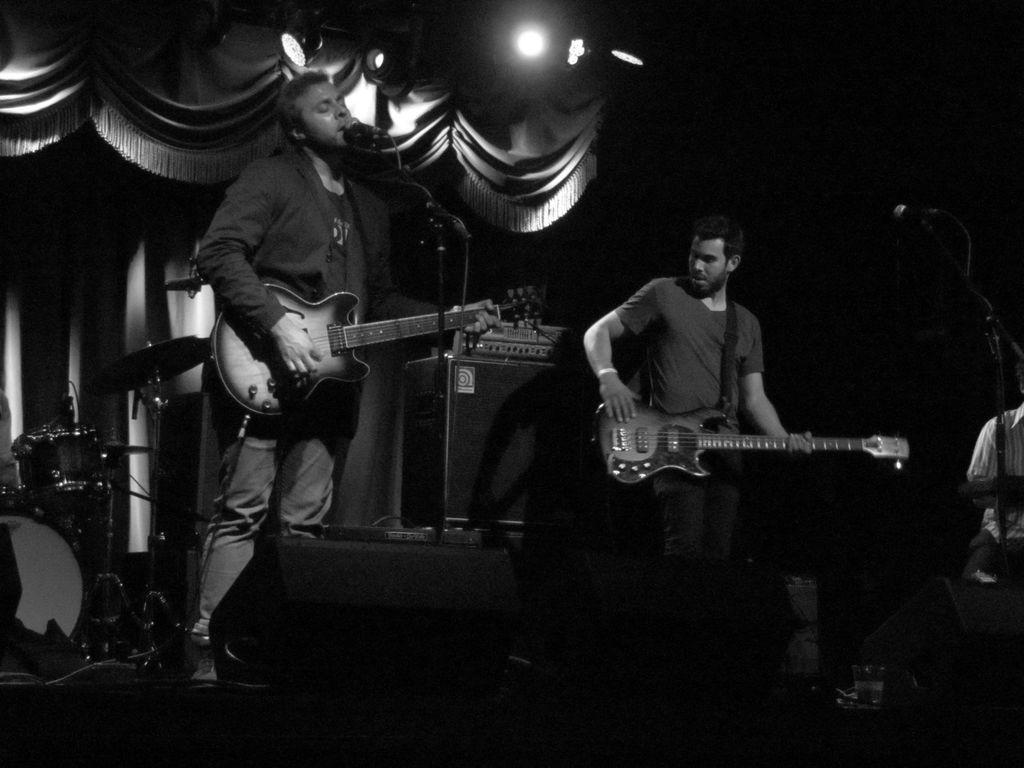How many people are in the image? There are 2 people in the image. What are the people doing in the image? The people are playing guitar. What is in front of the people? There is a microphone in front of the people. What musical instrument is on the left side of the image? There are drums on the left side of the image. What can be seen at the back of the image? There are curtains at the back of the image. What is visible in the image that might provide lighting? There are lights visible in the image. What type of beef is being served at the concert in the image? There is no beef or concert present in the image; it features two people playing guitar with a microphone and drums nearby. 